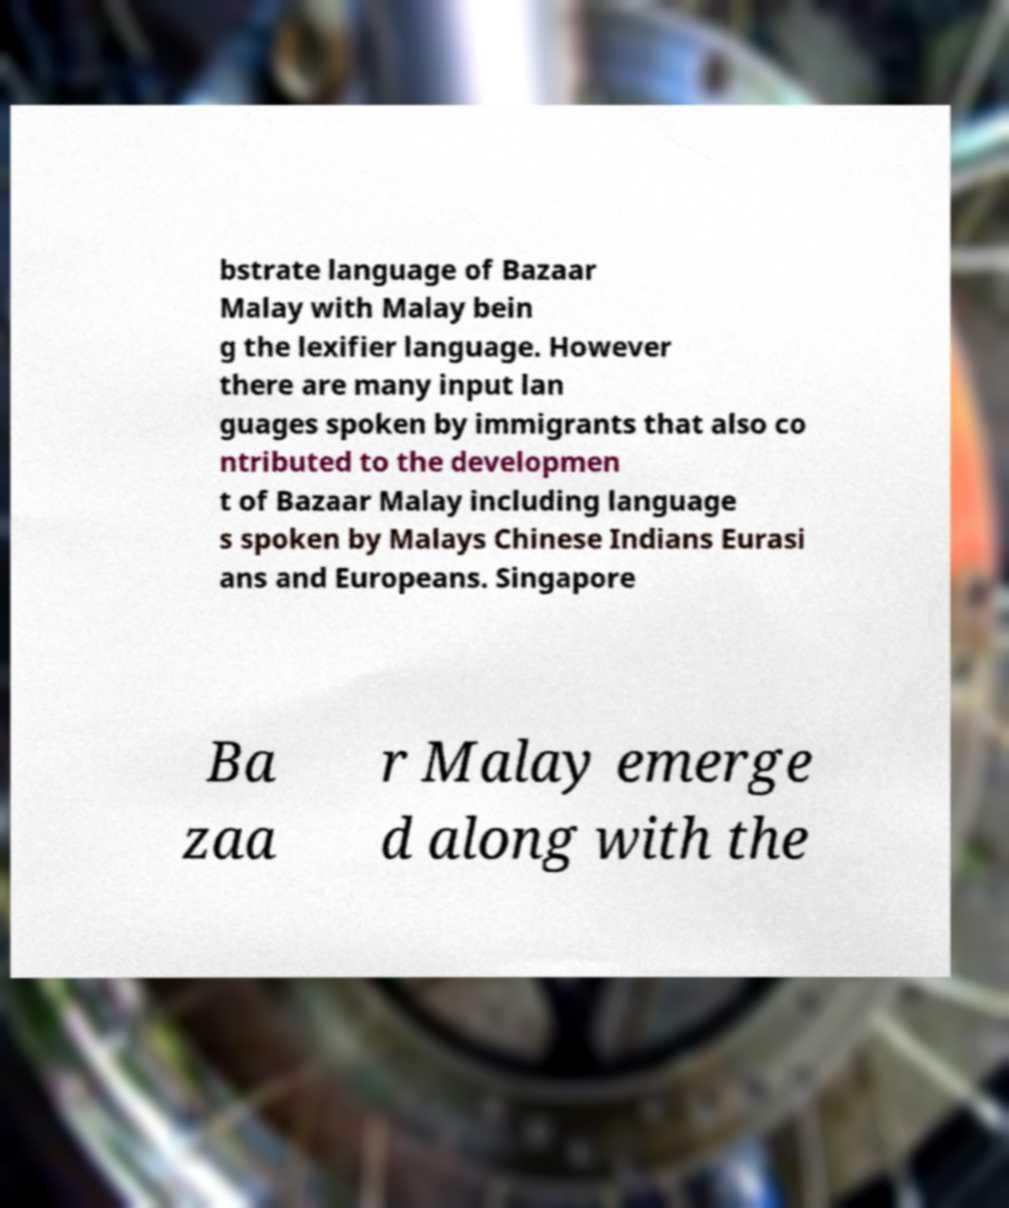Can you read and provide the text displayed in the image?This photo seems to have some interesting text. Can you extract and type it out for me? bstrate language of Bazaar Malay with Malay bein g the lexifier language. However there are many input lan guages spoken by immigrants that also co ntributed to the developmen t of Bazaar Malay including language s spoken by Malays Chinese Indians Eurasi ans and Europeans. Singapore Ba zaa r Malay emerge d along with the 